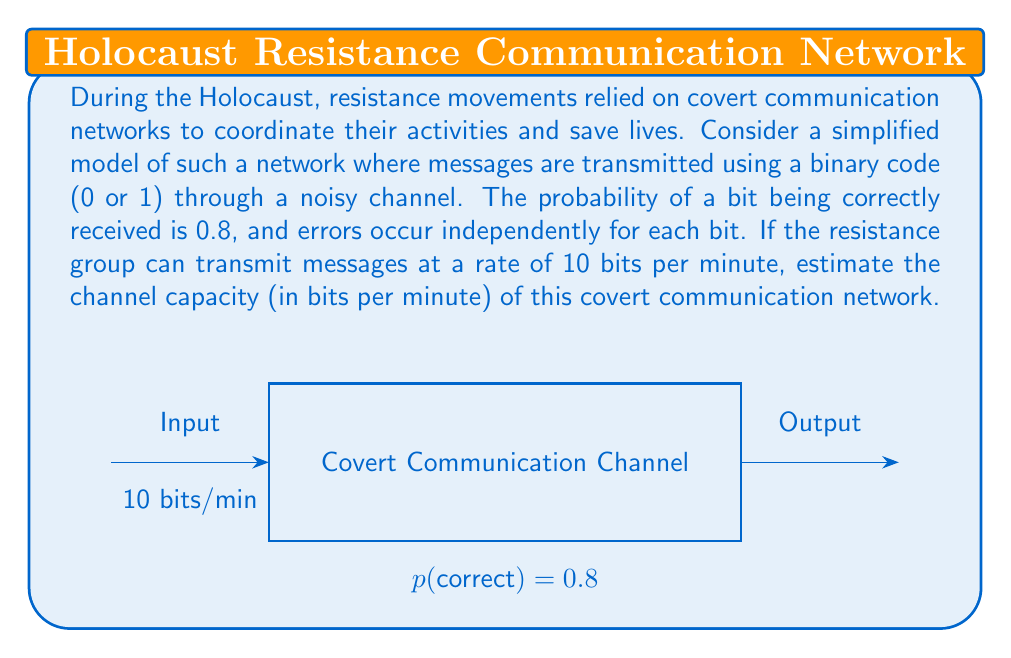Give your solution to this math problem. To solve this problem, we'll use the concept of channel capacity from information theory, considering the historical context of resistance movements during the Holocaust.

Step 1: Identify the channel model
The described channel is a binary symmetric channel (BSC) with a crossover probability of 0.2 (since the probability of correct transmission is 0.8).

Step 2: Calculate the channel capacity for a BSC
The capacity of a BSC is given by:
$$C = 1 - H(p)$$
where $H(p)$ is the binary entropy function and $p$ is the crossover probability.

Step 3: Calculate the binary entropy function
$$H(p) = -p \log_2(p) - (1-p) \log_2(1-p)$$
$$H(0.2) = -0.2 \log_2(0.2) - 0.8 \log_2(0.8)$$
$$H(0.2) \approx 0.7219$$

Step 4: Calculate the capacity per bit
$$C = 1 - H(0.2) \approx 1 - 0.7219 \approx 0.2781$$

Step 5: Calculate the channel capacity in bits per minute
Given that the resistance group can transmit at 10 bits per minute:
$$\text{Channel Capacity} = 10 \times 0.2781 \approx 2.781 \text{ bits/minute}$$

This result indicates that despite the noise in the channel, the resistance movement could reliably transmit about 2.781 bits of information per minute, which could be crucial for coordinating rescue operations and other resistance activities during the Holocaust.
Answer: 2.781 bits/minute 